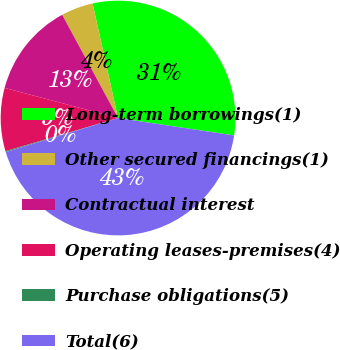Convert chart to OTSL. <chart><loc_0><loc_0><loc_500><loc_500><pie_chart><fcel>Long-term borrowings(1)<fcel>Other secured financings(1)<fcel>Contractual interest<fcel>Operating leases-premises(4)<fcel>Purchase obligations(5)<fcel>Total(6)<nl><fcel>30.85%<fcel>4.41%<fcel>12.97%<fcel>8.69%<fcel>0.13%<fcel>42.94%<nl></chart> 